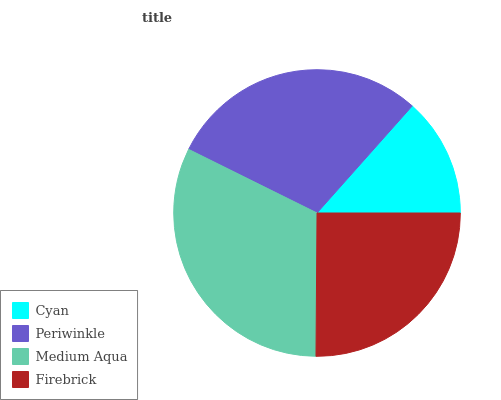Is Cyan the minimum?
Answer yes or no. Yes. Is Medium Aqua the maximum?
Answer yes or no. Yes. Is Periwinkle the minimum?
Answer yes or no. No. Is Periwinkle the maximum?
Answer yes or no. No. Is Periwinkle greater than Cyan?
Answer yes or no. Yes. Is Cyan less than Periwinkle?
Answer yes or no. Yes. Is Cyan greater than Periwinkle?
Answer yes or no. No. Is Periwinkle less than Cyan?
Answer yes or no. No. Is Periwinkle the high median?
Answer yes or no. Yes. Is Firebrick the low median?
Answer yes or no. Yes. Is Cyan the high median?
Answer yes or no. No. Is Cyan the low median?
Answer yes or no. No. 